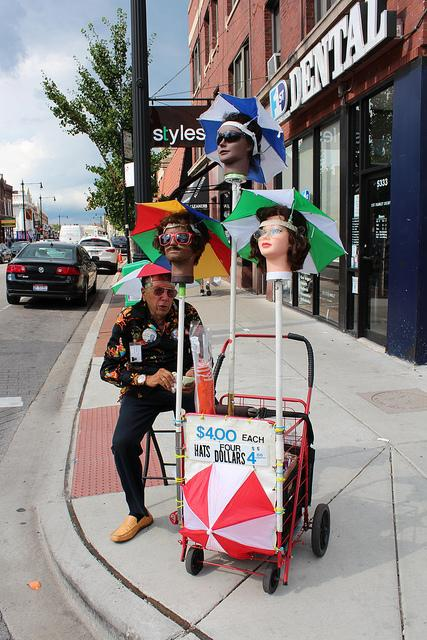What can the clinic on the right help you with? teeth 